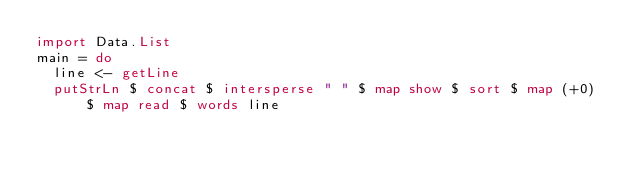<code> <loc_0><loc_0><loc_500><loc_500><_Haskell_>import Data.List
main = do
  line <- getLine
  putStrLn $ concat $ intersperse " " $ map show $ sort $ map (+0) $ map read $ words line

</code> 